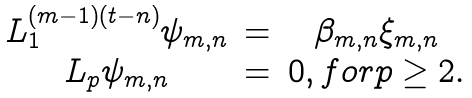Convert formula to latex. <formula><loc_0><loc_0><loc_500><loc_500>\begin{array} { c c c } L _ { 1 } ^ { ( m - 1 ) ( t - n ) } \psi _ { m , n } & = & \beta _ { m , n } \xi _ { m , n } \\ L _ { p } \psi _ { m , n } & = & 0 , f o r p \geq 2 . \end{array}</formula> 